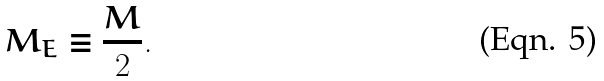Convert formula to latex. <formula><loc_0><loc_0><loc_500><loc_500>M _ { E } \equiv \frac { M } { 2 } .</formula> 